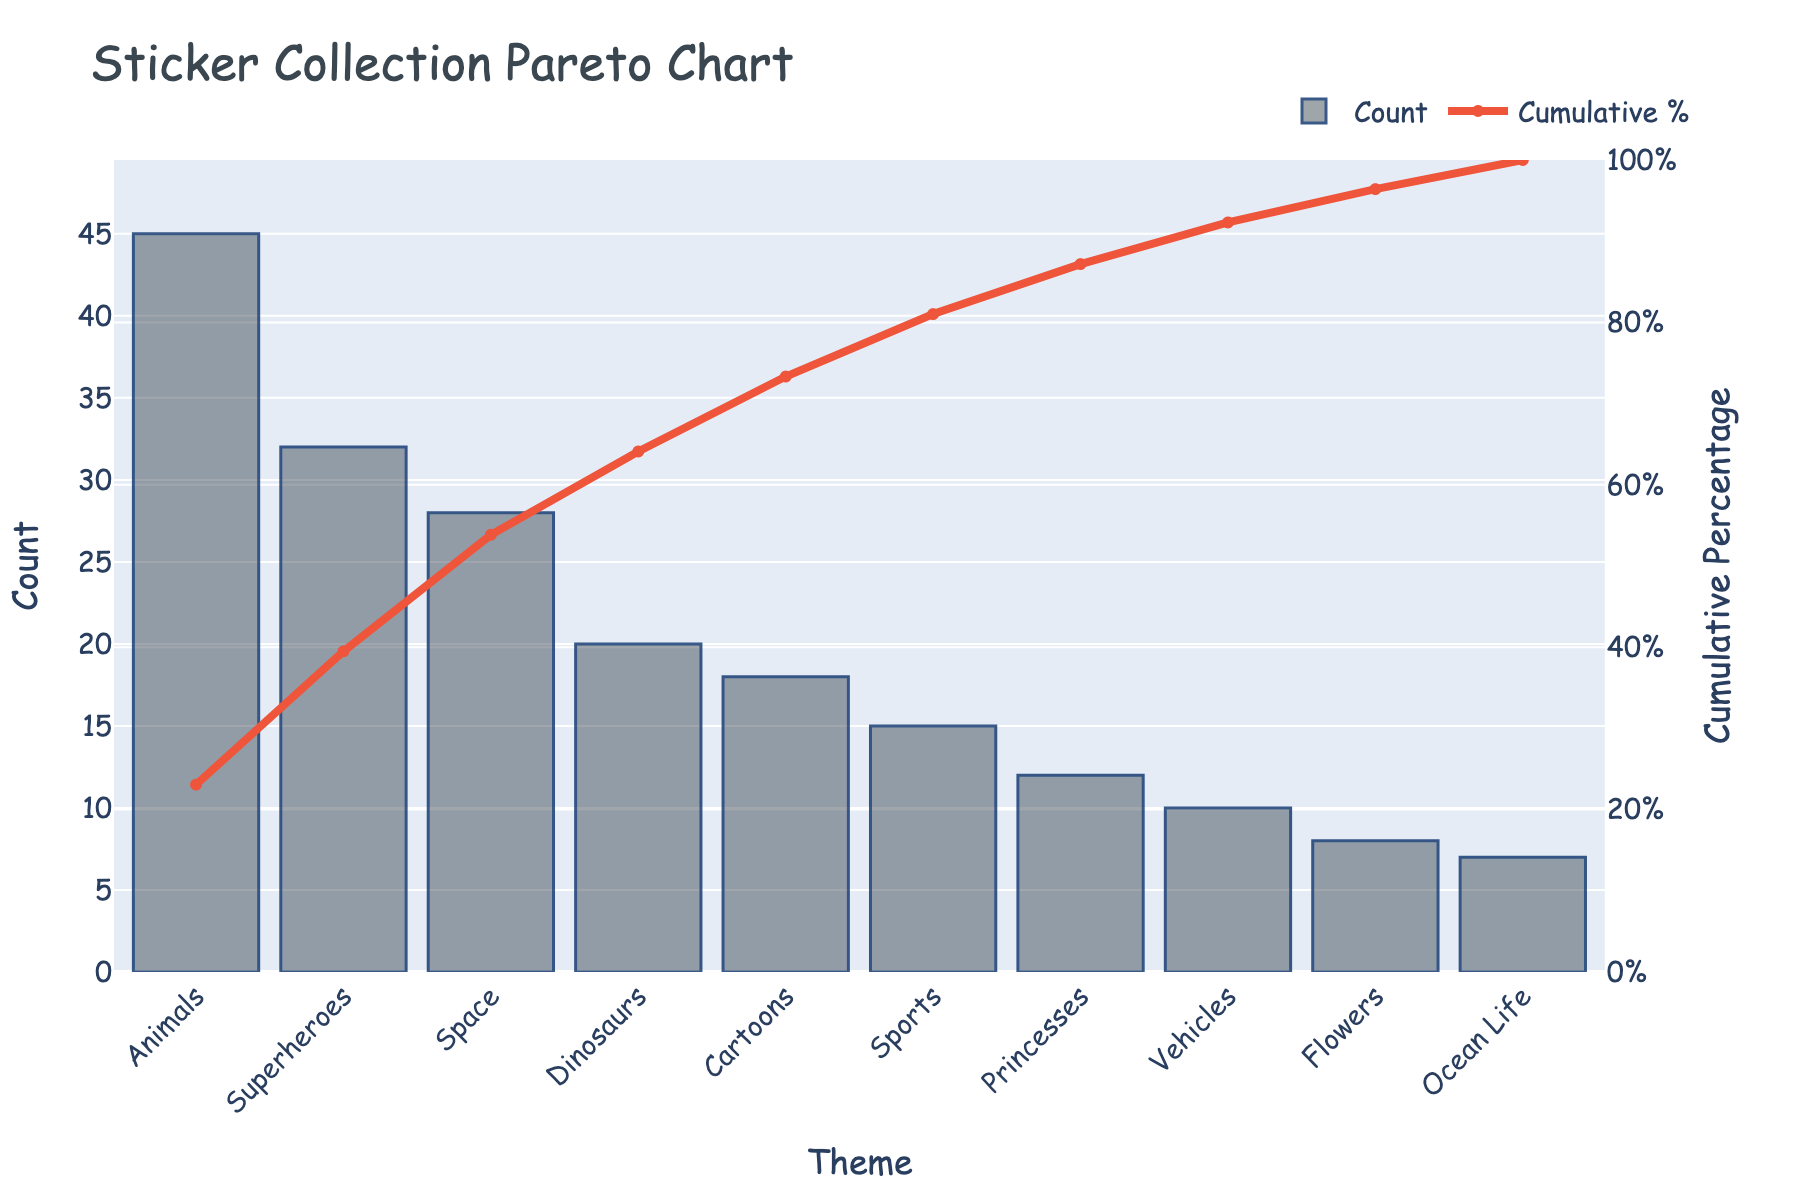What is the title of the chart? The title is located at the top of the chart and is written in a larger font size.
Answer: Sticker Collection Pareto Chart How many themes are displayed in the chart? Count the number of bars or the number of theme labels on the x-axis.
Answer: 10 Which theme has the highest count of stickers? Look for the tallest bar in the chart, as it represents the theme with the highest count.
Answer: Animals What is the cumulative percentage after the first three themes? Add up the cumulative percentages of the first three themes from the line chart component (Animals, Superheroes, Space).
Answer: 66.74% How does the count of stickers for Superheroes compare to that of Dinosaurs? Locate both bars for Superheroes and Dinosaurs and compare their heights or the values on the y-axis.
Answer: Superheroes (32) is higher than Dinosaurs (20) What is the cumulative percentage for Princesses? Find the point on the line chart that corresponds to Princesses and read its cumulative percentage value.
Answer: 91.97% What is the difference in sticker count between Cartoons and Sports? Subtract the count of Sports stickers from the count of Cartoons stickers.
Answer: 3 (18 - 15) Which theme contributes to pushing the cumulative percentage just over 80%? Look for the point on the cumulative percentage line that just surpasses 80%, then identify the theme.
Answer: Princesses How many themes have a count of stickers less than 20? Count the number of bars shorter than the value 20 on the y-axis.
Answer: 5 (Cartoons, Sports, Princesses, Vehicles, Flowers, Ocean Life) What is the combined count of stickers for the three themes with the lowest counts? Add the counts of the three themes with the smallest bars on the chart.
Answer: 25 (Flowers 8 + Ocean Life 7 + Vehicles 10) 